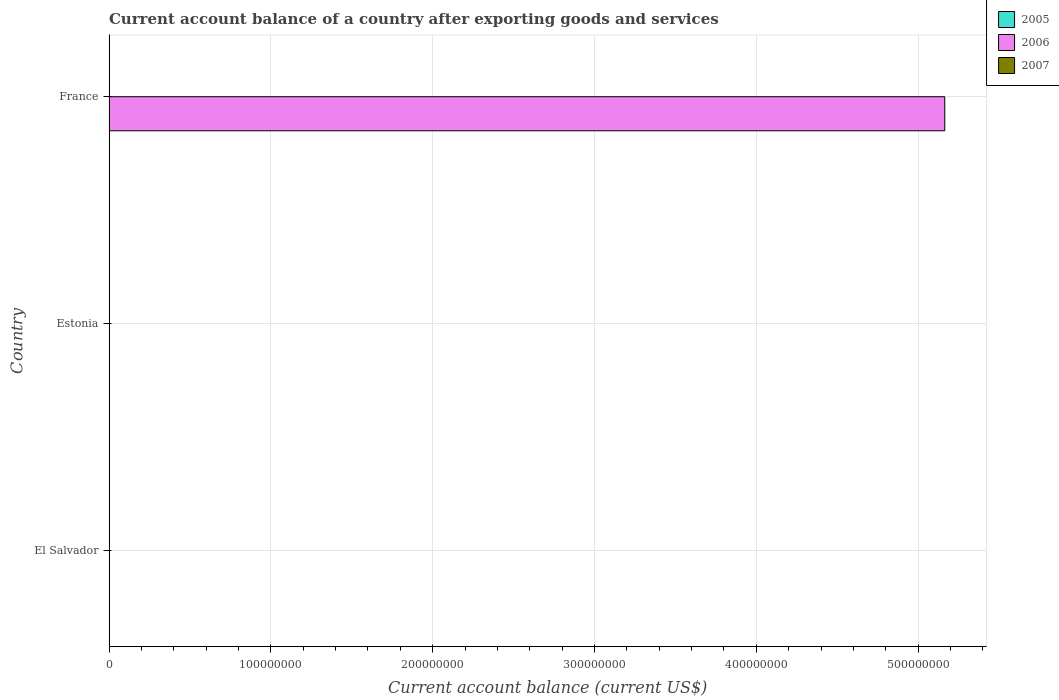How many different coloured bars are there?
Provide a short and direct response. 1. Are the number of bars on each tick of the Y-axis equal?
Ensure brevity in your answer.  No. How many bars are there on the 3rd tick from the bottom?
Ensure brevity in your answer.  1. In how many cases, is the number of bars for a given country not equal to the number of legend labels?
Your response must be concise. 3. Across all countries, what is the maximum account balance in 2006?
Give a very brief answer. 5.16e+08. Across all countries, what is the minimum account balance in 2007?
Offer a terse response. 0. What is the total account balance in 2007 in the graph?
Give a very brief answer. 0. What is the difference between the account balance in 2006 in Estonia and the account balance in 2007 in France?
Provide a short and direct response. 0. What is the average account balance in 2006 per country?
Ensure brevity in your answer.  1.72e+08. What is the difference between the highest and the lowest account balance in 2006?
Make the answer very short. 5.16e+08. Is it the case that in every country, the sum of the account balance in 2006 and account balance in 2007 is greater than the account balance in 2005?
Make the answer very short. No. How many bars are there?
Ensure brevity in your answer.  1. Are all the bars in the graph horizontal?
Give a very brief answer. Yes. Does the graph contain any zero values?
Provide a short and direct response. Yes. How are the legend labels stacked?
Make the answer very short. Vertical. What is the title of the graph?
Give a very brief answer. Current account balance of a country after exporting goods and services. What is the label or title of the X-axis?
Your response must be concise. Current account balance (current US$). What is the Current account balance (current US$) of 2005 in El Salvador?
Provide a succinct answer. 0. What is the Current account balance (current US$) in 2006 in El Salvador?
Give a very brief answer. 0. What is the Current account balance (current US$) of 2007 in El Salvador?
Make the answer very short. 0. What is the Current account balance (current US$) of 2005 in Estonia?
Make the answer very short. 0. What is the Current account balance (current US$) of 2007 in Estonia?
Your answer should be very brief. 0. What is the Current account balance (current US$) of 2006 in France?
Offer a terse response. 5.16e+08. What is the Current account balance (current US$) in 2007 in France?
Give a very brief answer. 0. Across all countries, what is the maximum Current account balance (current US$) of 2006?
Your answer should be very brief. 5.16e+08. Across all countries, what is the minimum Current account balance (current US$) in 2006?
Provide a succinct answer. 0. What is the total Current account balance (current US$) in 2005 in the graph?
Offer a terse response. 0. What is the total Current account balance (current US$) in 2006 in the graph?
Your answer should be compact. 5.16e+08. What is the average Current account balance (current US$) in 2006 per country?
Offer a very short reply. 1.72e+08. What is the difference between the highest and the lowest Current account balance (current US$) in 2006?
Offer a very short reply. 5.16e+08. 